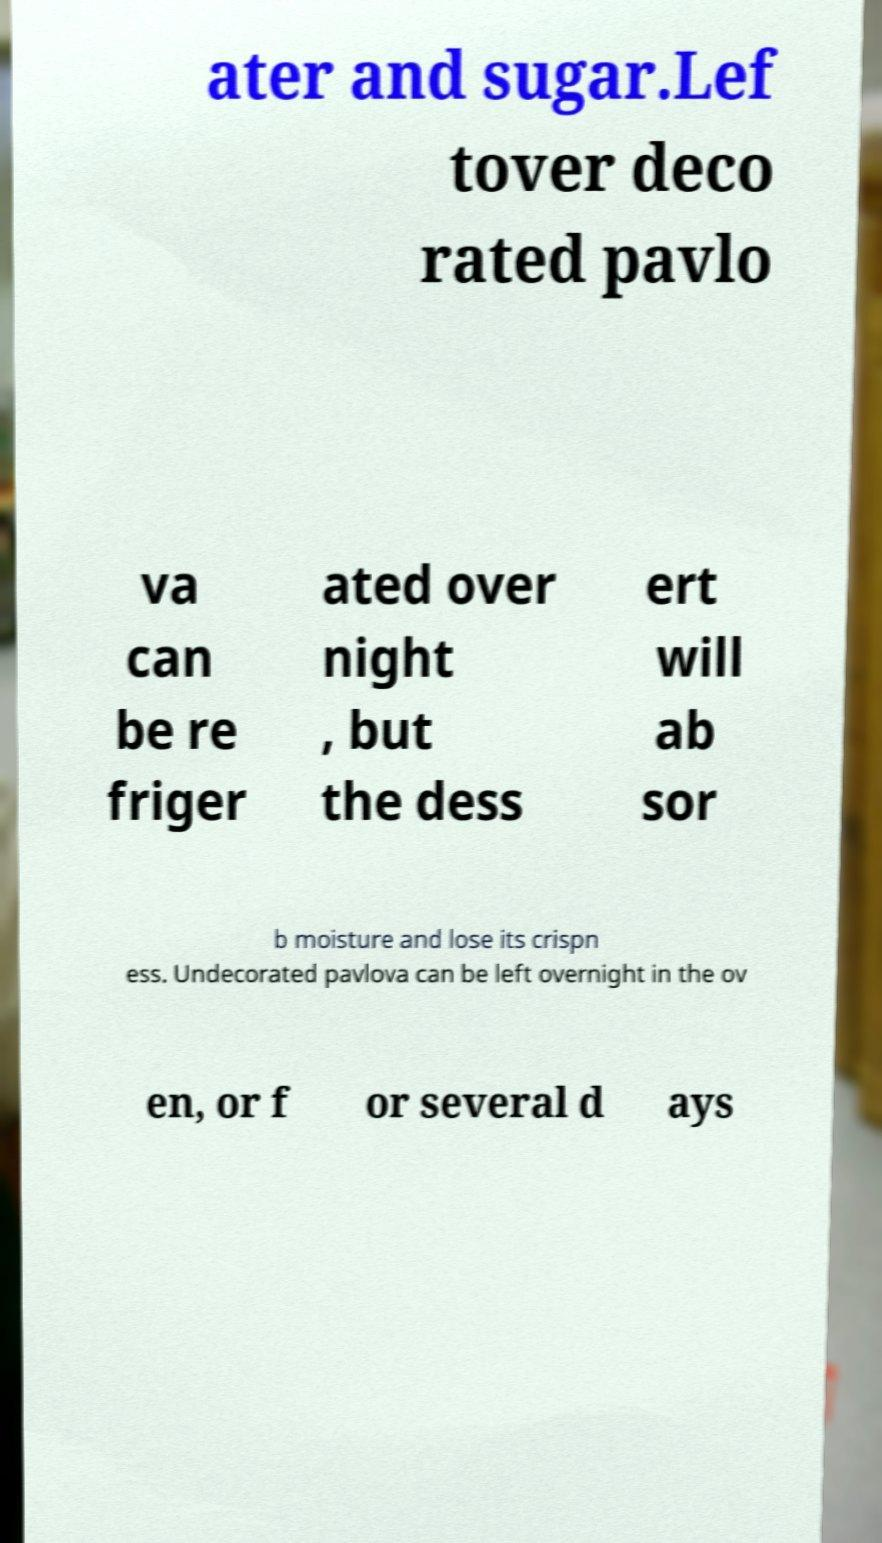Please identify and transcribe the text found in this image. ater and sugar.Lef tover deco rated pavlo va can be re friger ated over night , but the dess ert will ab sor b moisture and lose its crispn ess. Undecorated pavlova can be left overnight in the ov en, or f or several d ays 